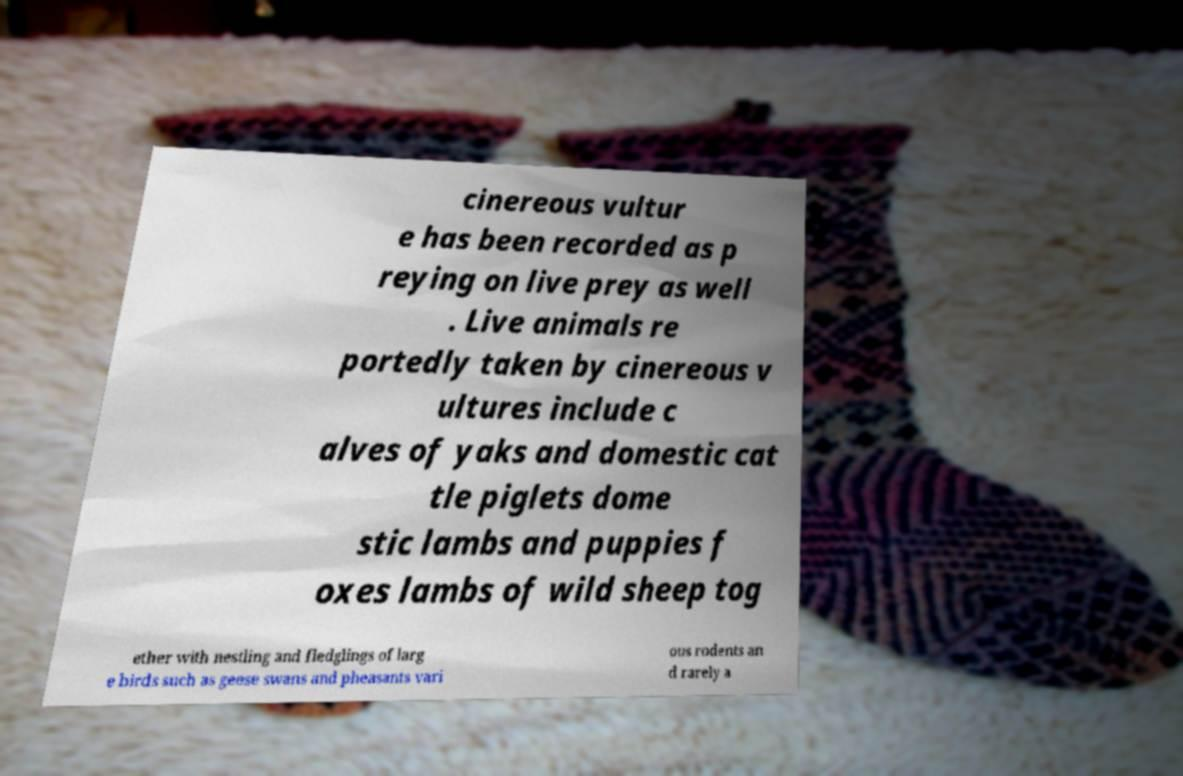Could you extract and type out the text from this image? cinereous vultur e has been recorded as p reying on live prey as well . Live animals re portedly taken by cinereous v ultures include c alves of yaks and domestic cat tle piglets dome stic lambs and puppies f oxes lambs of wild sheep tog ether with nestling and fledglings of larg e birds such as geese swans and pheasants vari ous rodents an d rarely a 